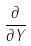<formula> <loc_0><loc_0><loc_500><loc_500>\frac { \partial } { \partial Y }</formula> 